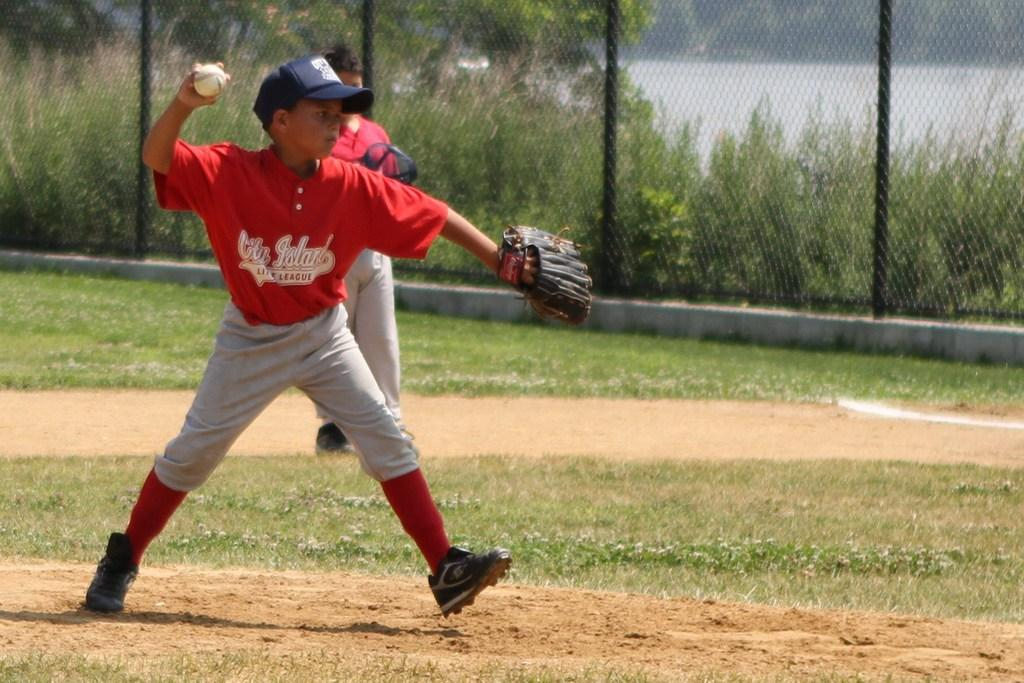<image>
Give a short and clear explanation of the subsequent image. Young boy throws a pitch for City Island Little League. 